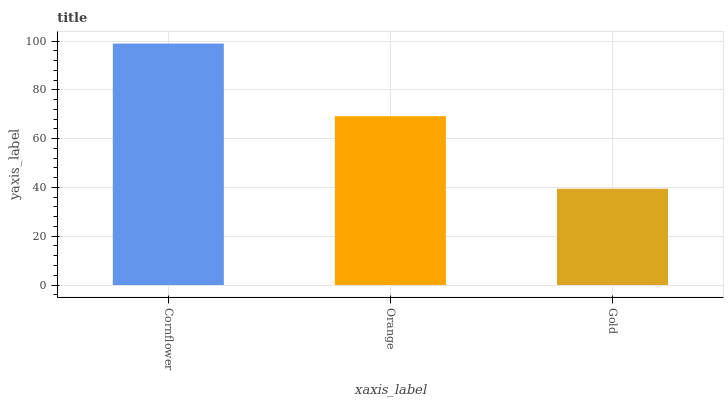Is Gold the minimum?
Answer yes or no. Yes. Is Cornflower the maximum?
Answer yes or no. Yes. Is Orange the minimum?
Answer yes or no. No. Is Orange the maximum?
Answer yes or no. No. Is Cornflower greater than Orange?
Answer yes or no. Yes. Is Orange less than Cornflower?
Answer yes or no. Yes. Is Orange greater than Cornflower?
Answer yes or no. No. Is Cornflower less than Orange?
Answer yes or no. No. Is Orange the high median?
Answer yes or no. Yes. Is Orange the low median?
Answer yes or no. Yes. Is Cornflower the high median?
Answer yes or no. No. Is Cornflower the low median?
Answer yes or no. No. 